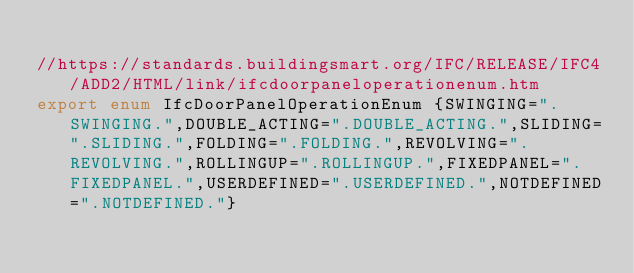<code> <loc_0><loc_0><loc_500><loc_500><_TypeScript_>
//https://standards.buildingsmart.org/IFC/RELEASE/IFC4/ADD2/HTML/link/ifcdoorpaneloperationenum.htm
export enum IfcDoorPanelOperationEnum {SWINGING=".SWINGING.",DOUBLE_ACTING=".DOUBLE_ACTING.",SLIDING=".SLIDING.",FOLDING=".FOLDING.",REVOLVING=".REVOLVING.",ROLLINGUP=".ROLLINGUP.",FIXEDPANEL=".FIXEDPANEL.",USERDEFINED=".USERDEFINED.",NOTDEFINED=".NOTDEFINED."}
</code> 